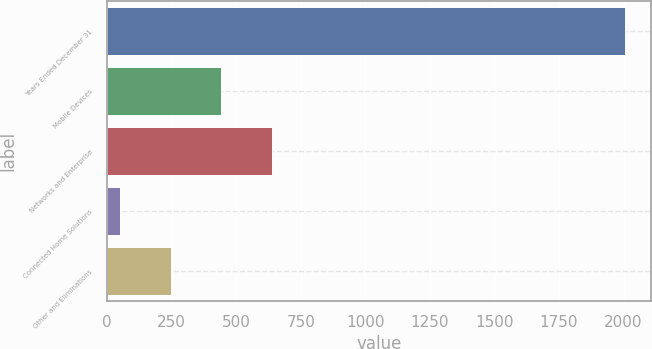Convert chart. <chart><loc_0><loc_0><loc_500><loc_500><bar_chart><fcel>Years Ended December 31<fcel>Mobile Devices<fcel>Networks and Enterprise<fcel>Connected Home Solutions<fcel>Other and Eliminations<nl><fcel>2005<fcel>441.8<fcel>637.2<fcel>51<fcel>246.4<nl></chart> 